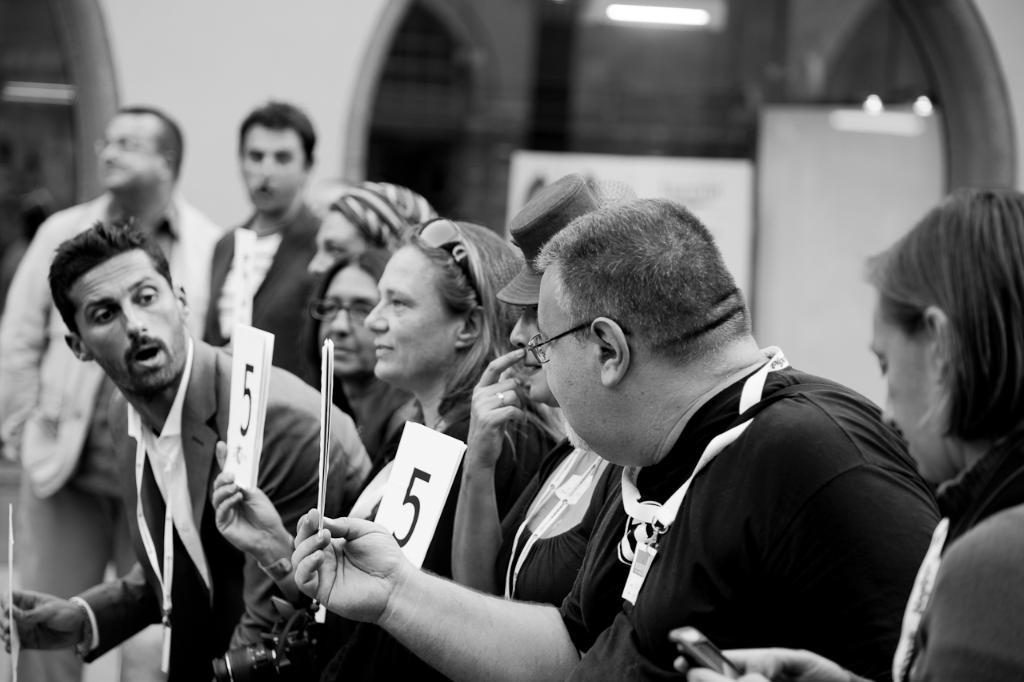What is the main subject of the image? The main subject of the image is a group of people. What are some of the people in the image doing? Some of the people are standing, and some are holding books in their hands. What can be seen in the background of the image? There is a house in the background of the image. What type of porter is serving drinks to the people in the image? There is no porter present in the image, nor are any drinks being served. Can you see any rats running around in the image? There are no rats visible in the image; the image only features a group of people and a house in the background. 